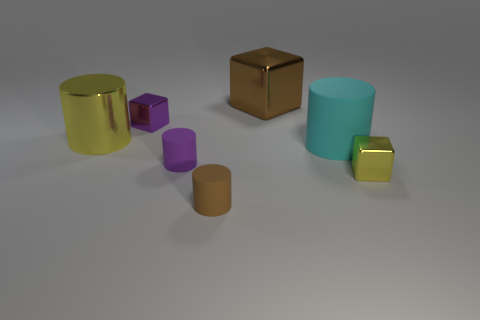There is a brown object that is behind the small metallic block to the right of the brown cube; what shape is it?
Your response must be concise. Cube. What shape is the small matte object to the right of the small purple matte cylinder?
Your answer should be very brief. Cylinder. What number of metal cylinders are the same color as the big cube?
Your response must be concise. 0. What color is the large shiny cylinder?
Ensure brevity in your answer.  Yellow. What number of small matte cylinders are in front of the tiny metal thing to the right of the brown matte cylinder?
Make the answer very short. 1. There is a purple shiny thing; does it have the same size as the yellow metal thing that is in front of the purple matte thing?
Your response must be concise. Yes. Do the yellow cube and the brown matte object have the same size?
Provide a succinct answer. Yes. Are there any metallic things of the same size as the brown rubber object?
Ensure brevity in your answer.  Yes. There is a tiny cube that is left of the large metal cube; what material is it?
Offer a very short reply. Metal. The small cylinder that is made of the same material as the tiny brown thing is what color?
Your answer should be very brief. Purple. 